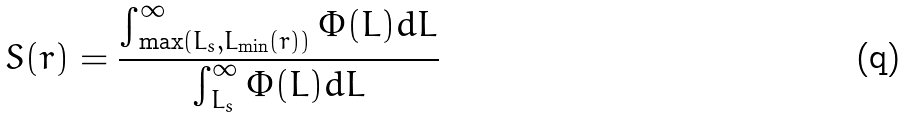<formula> <loc_0><loc_0><loc_500><loc_500>S ( r ) = \frac { \int _ { \max ( L _ { s } , L _ { \min } ( r ) ) } ^ { \infty } \Phi ( L ) d L } { \int _ { L _ { s } } ^ { \infty } \Phi ( L ) d L }</formula> 